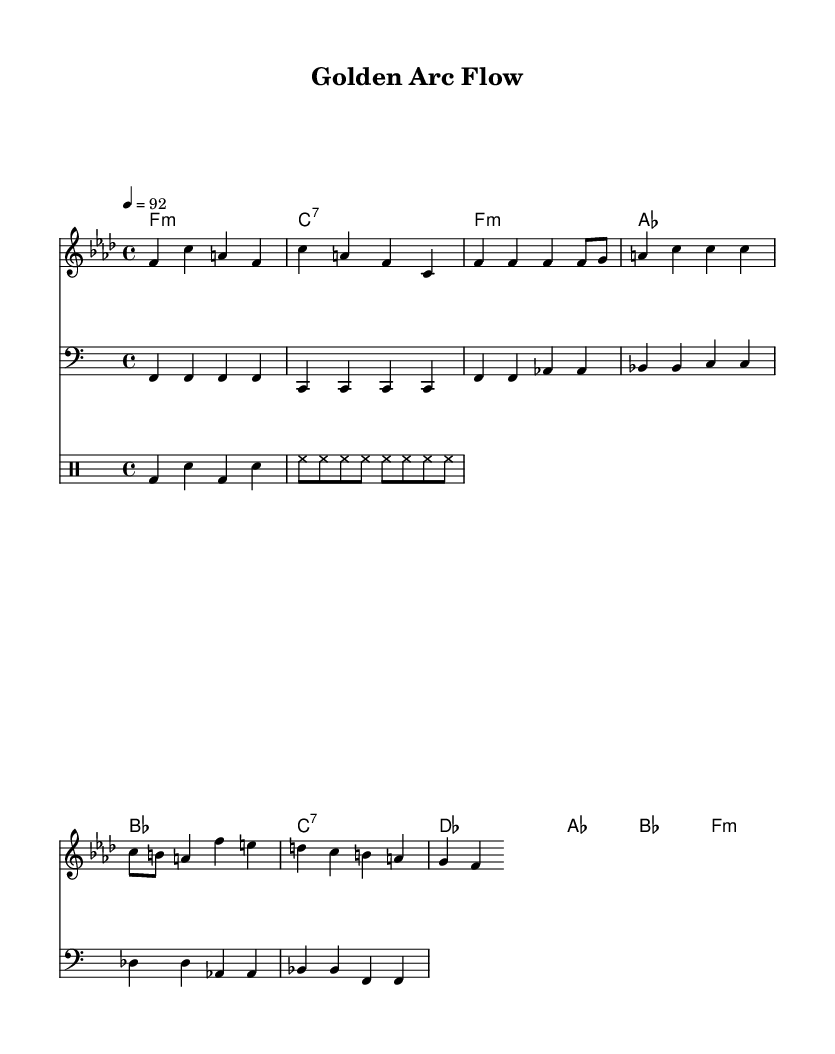What is the key signature of this music? The key signature is F minor, indicated by four flats in the score. You can identify this by looking at the key signature at the beginning of the sheet music.
Answer: F minor What is the time signature of this music? The time signature is 4/4, shown at the beginning of the sheet music. This means there are four beats in each measure, and a quarter note gets one beat.
Answer: 4/4 What is the tempo marking of this music? The tempo marking is 92 beats per minute, stated at the beginning of the piece. This indicates how fast or slow the music should be played.
Answer: 92 What type of chord is prevalent in the verse section? The chord prevalent in the verse section is minor. You can analyze the chords shown in the chord symbols above the melody, focusing on how many are minor compared to other types.
Answer: minor How does the chorus lyrically reflect the structure of character arcs? The chorus emphasizes the theme of evolution and smooth distortion, paralleling character development in narratives. This can be inferred by analyzing the lyrical content about character arcs and their connection to proportions.
Answer: evolution What rhythmic element is consistent throughout the verse? The consistent rhythmic element throughout the verse is eighth notes, as indicated by the notation in the melody line. You can see this represented by the smaller note values that drive the flow of the verse.
Answer: eighth notes In the context of the song, what does "golden arc" symbolize? "Golden arc" symbolizes a perfect proportion in storytelling, aligning with character development akin to the golden ratio. This is derived from the thematic focus of the lyrics and musical structure that mirrors mathematical concepts.
Answer: perfect proportion 